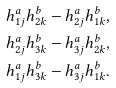Convert formula to latex. <formula><loc_0><loc_0><loc_500><loc_500>& h ^ { a } _ { 1 j } h ^ { b } _ { 2 k } - h ^ { a } _ { 2 j } h ^ { b } _ { 1 k } , \\ & h ^ { a } _ { 2 j } h ^ { b } _ { 3 k } - h ^ { a } _ { 3 j } h ^ { b } _ { 2 k } , \\ & h ^ { a } _ { 1 j } h ^ { b } _ { 3 k } - h ^ { a } _ { 3 j } h ^ { b } _ { 1 k } .</formula> 